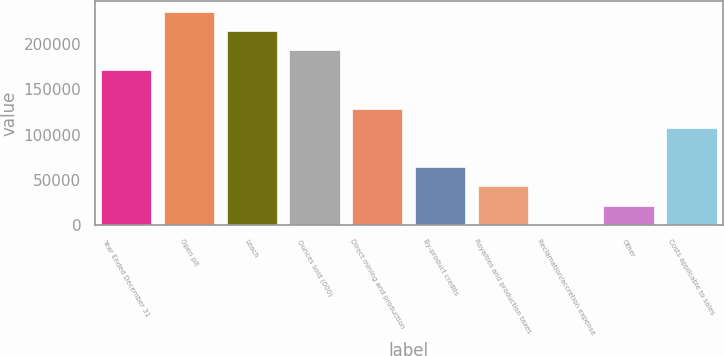<chart> <loc_0><loc_0><loc_500><loc_500><bar_chart><fcel>Year Ended December 31<fcel>Open pit<fcel>Leach<fcel>Ounces sold (000)<fcel>Direct mining and production<fcel>By-product credits<fcel>Royalties and production taxes<fcel>Reclamation/accretion expense<fcel>Other<fcel>Costs applicable to sales<nl><fcel>171302<fcel>235540<fcel>214127<fcel>192714<fcel>128477<fcel>64239.5<fcel>42827<fcel>2<fcel>21414.5<fcel>107064<nl></chart> 